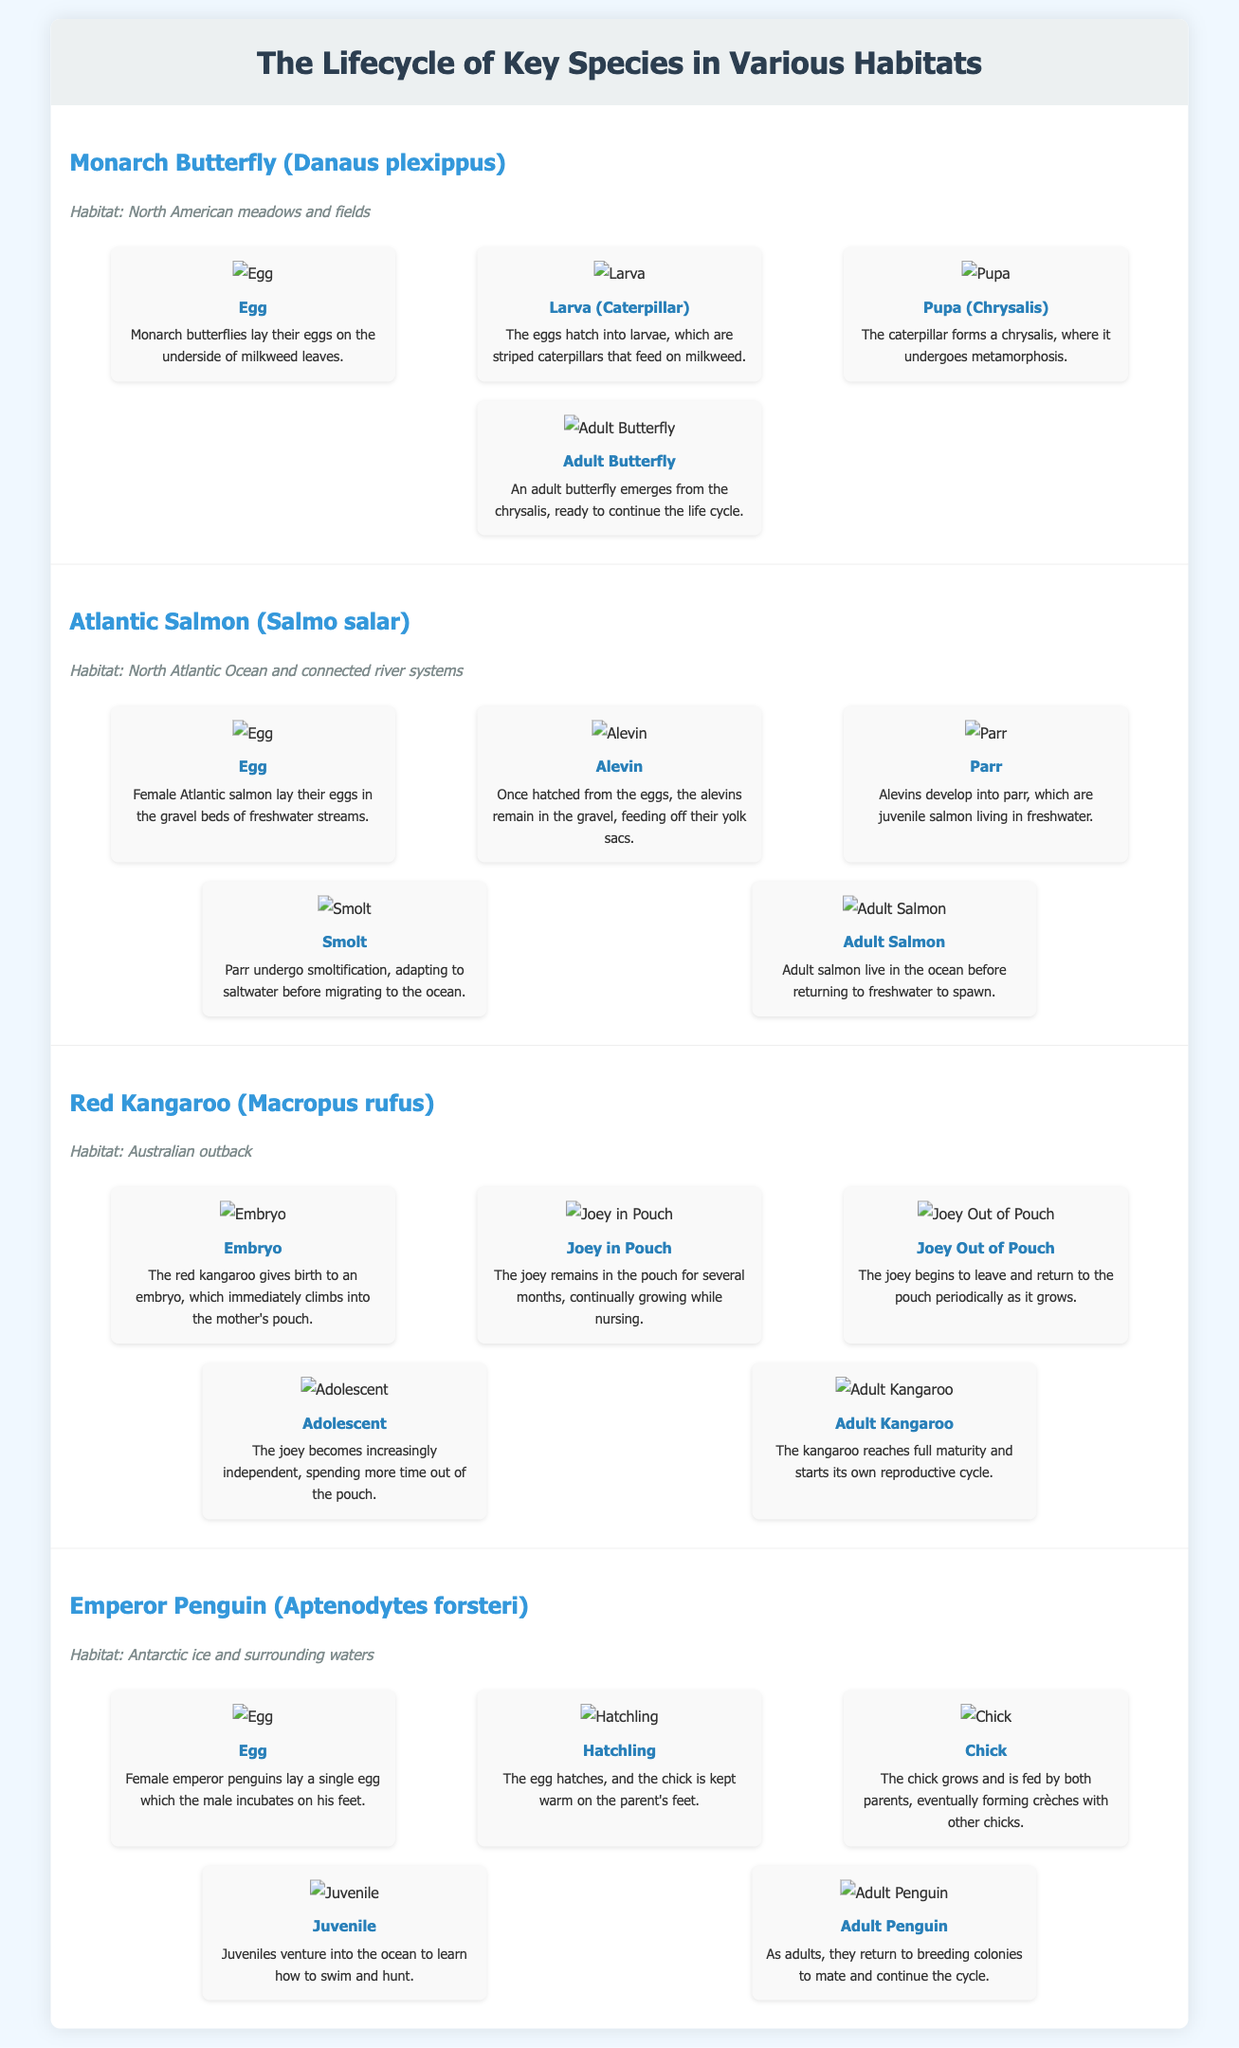What species is highlighted first in the infographic? The infographic presents the Monarch Butterfly as the first species in the list.
Answer: Monarch Butterfly (Danaus plexippus) How many stages are there in the lifecycle of the Atlantic Salmon? The Atlantic Salmon lifecycle consists of five distinct stages outlined in the document.
Answer: 5 Which habitat is associated with the Red Kangaroo? The document mentions the Australian outback as the habitat for the Red Kangaroo.
Answer: Australian outback What is the final stage of the lifecycle for the Emperor Penguin? The last stage in the Emperor Penguin's lifecycle is described as the Adult Penguin, indicating maturity in their development.
Answer: Adult Penguin What does the Alevin stage of the Atlantic Salmon feed on? The Alevin stage of the Atlantic Salmon feeds off their yolk sacs after hatching from the eggs.
Answer: Yolk sacs At which stage does the Monarch Butterfly undergo metamorphosis? The Monarch Butterfly undergoes metamorphosis during the Pupa stage, when it is in a chrysalis.
Answer: Pupa (Chrysalis) From which leaf do Monarch Butterflies lay their eggs? Monarch Butterflies lay their eggs specifically on the underside of milkweed leaves.
Answer: Milkweed leaves What are juvenile emperor penguins learning to do during their lifecycle? Juvenile emperor penguins venture into the ocean to learn how to swim and hunt, as noted in the document.
Answer: Swim and hunt What is the primary purpose of the infographic? The infographic serves to visually represent and explain the lifecycle stages of various species in different habitats.
Answer: Lifecycle representation 